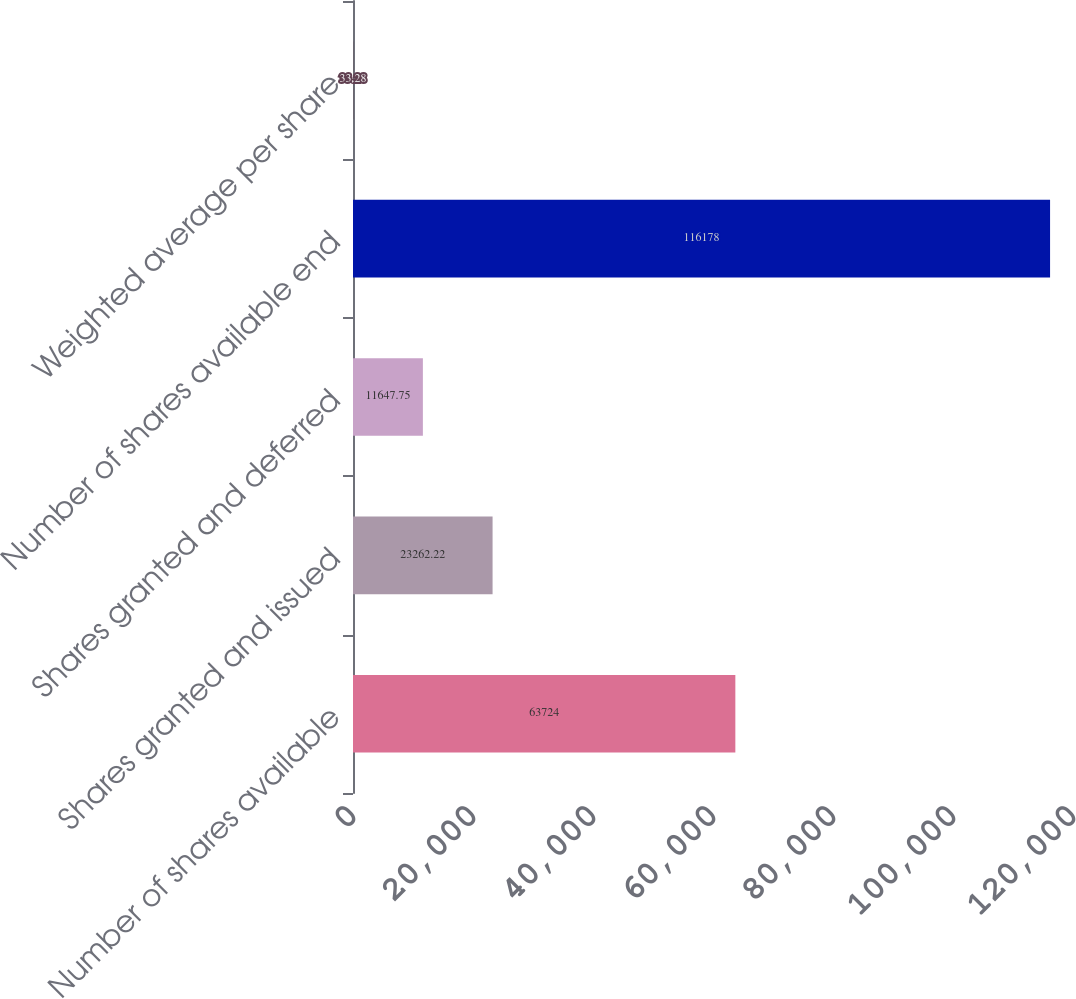Convert chart. <chart><loc_0><loc_0><loc_500><loc_500><bar_chart><fcel>Number of shares available<fcel>Shares granted and issued<fcel>Shares granted and deferred<fcel>Number of shares available end<fcel>Weighted average per share<nl><fcel>63724<fcel>23262.2<fcel>11647.8<fcel>116178<fcel>33.28<nl></chart> 